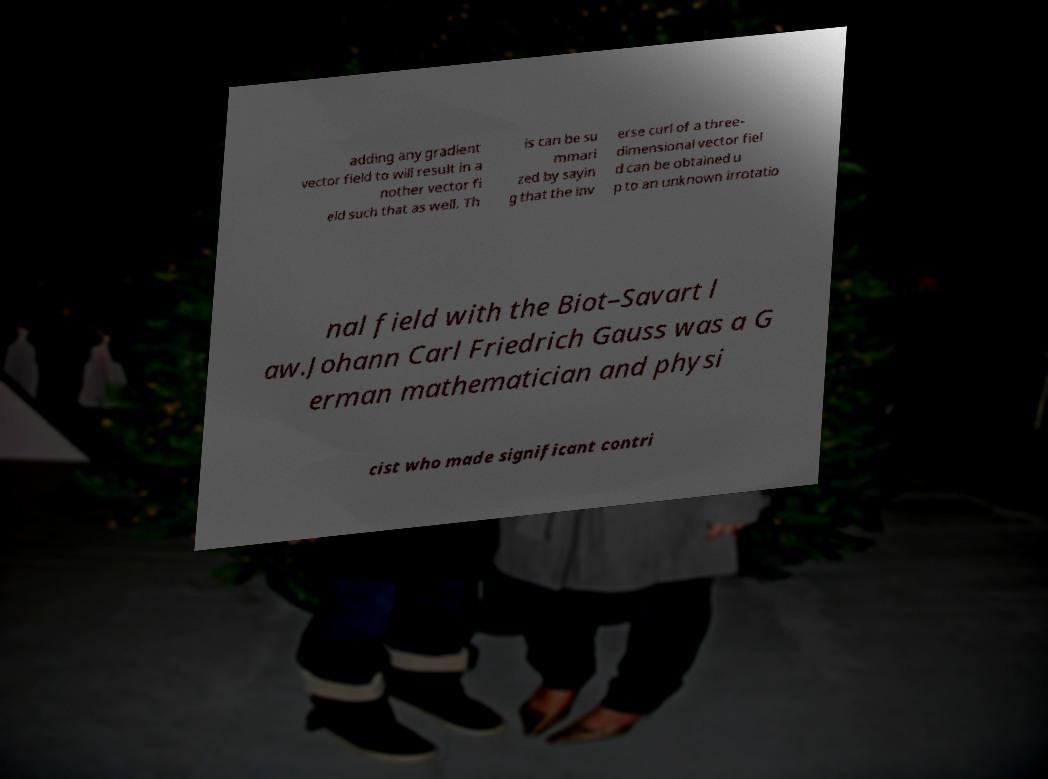What messages or text are displayed in this image? I need them in a readable, typed format. adding any gradient vector field to will result in a nother vector fi eld such that as well. Th is can be su mmari zed by sayin g that the inv erse curl of a three- dimensional vector fiel d can be obtained u p to an unknown irrotatio nal field with the Biot–Savart l aw.Johann Carl Friedrich Gauss was a G erman mathematician and physi cist who made significant contri 